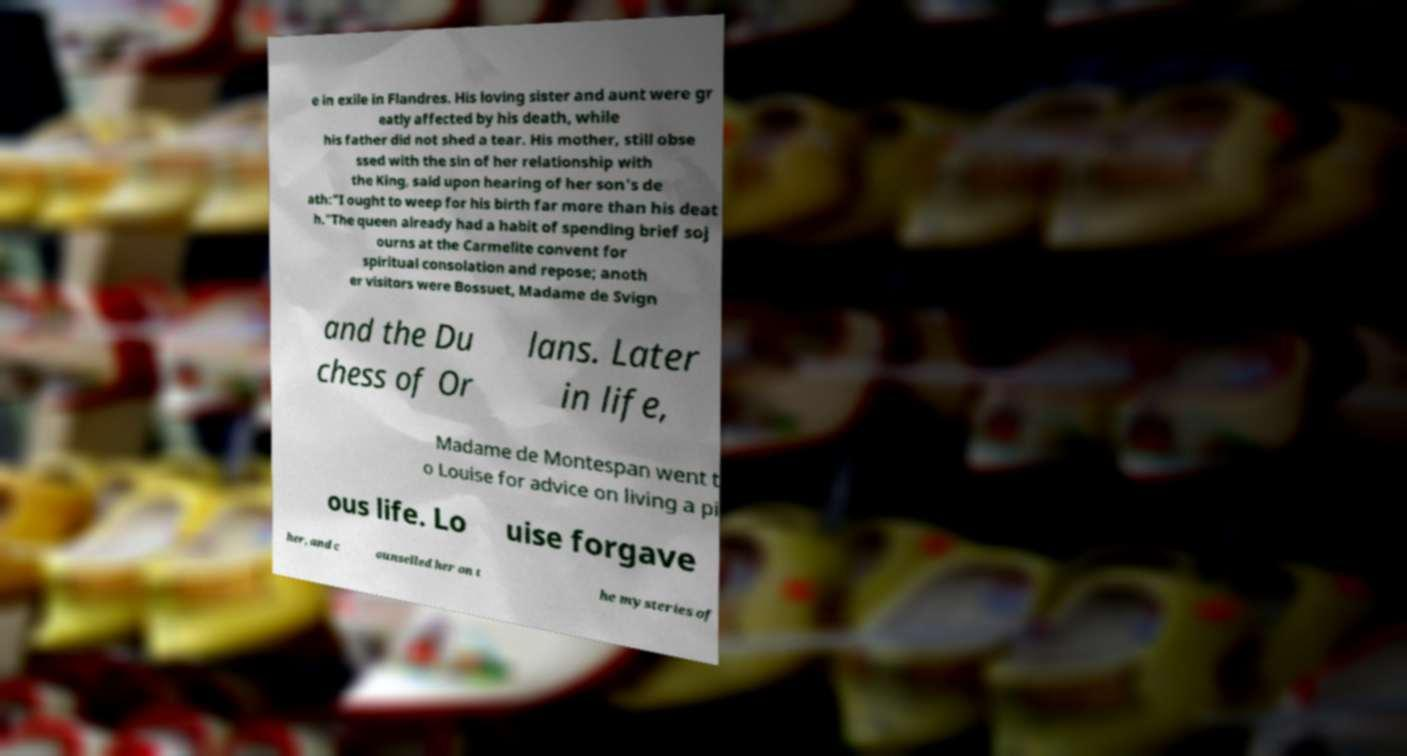There's text embedded in this image that I need extracted. Can you transcribe it verbatim? e in exile in Flandres. His loving sister and aunt were gr eatly affected by his death, while his father did not shed a tear. His mother, still obse ssed with the sin of her relationship with the King, said upon hearing of her son's de ath:"I ought to weep for his birth far more than his deat h."The queen already had a habit of spending brief soj ourns at the Carmelite convent for spiritual consolation and repose; anoth er visitors were Bossuet, Madame de Svign and the Du chess of Or lans. Later in life, Madame de Montespan went t o Louise for advice on living a pi ous life. Lo uise forgave her, and c ounselled her on t he mysteries of 